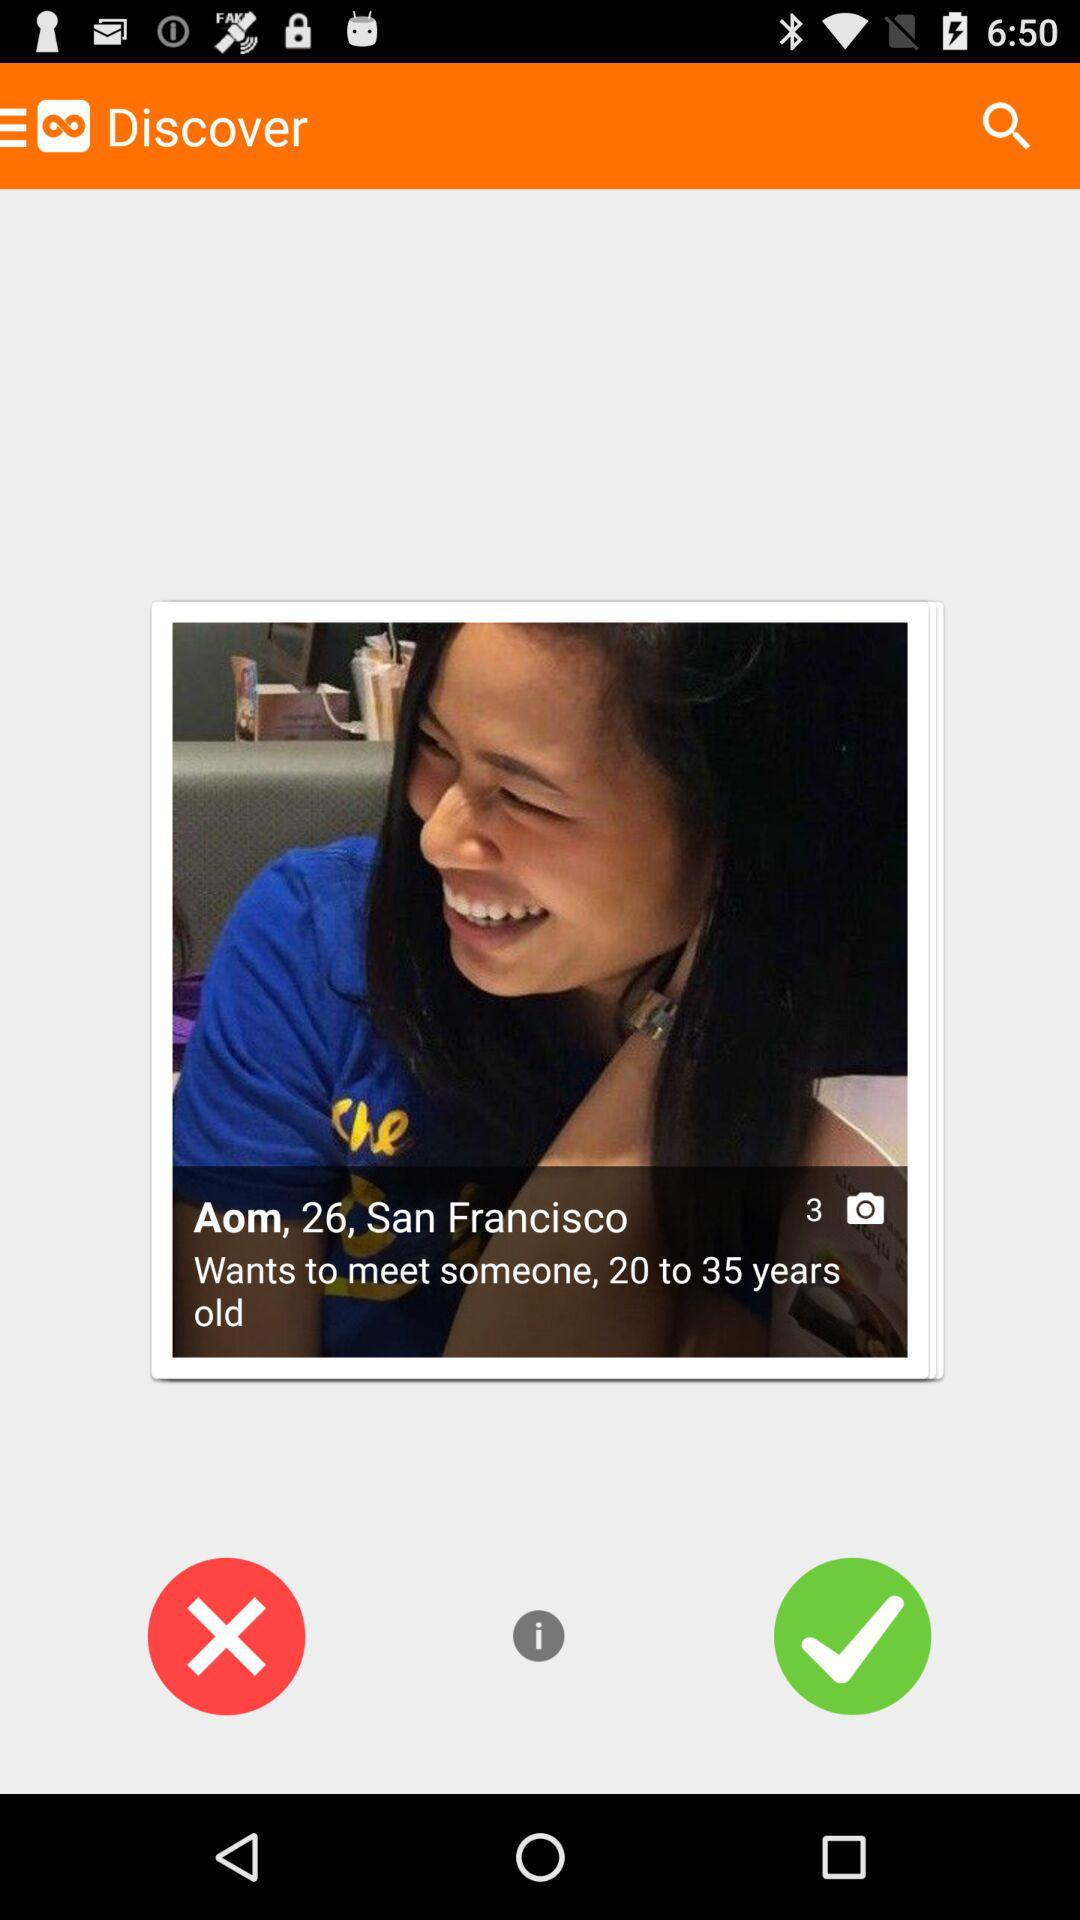To which age group, Aom wants to meet? To which age group does Aom want to meet? Aom wants to meet someone from 20 to 35 years old. 